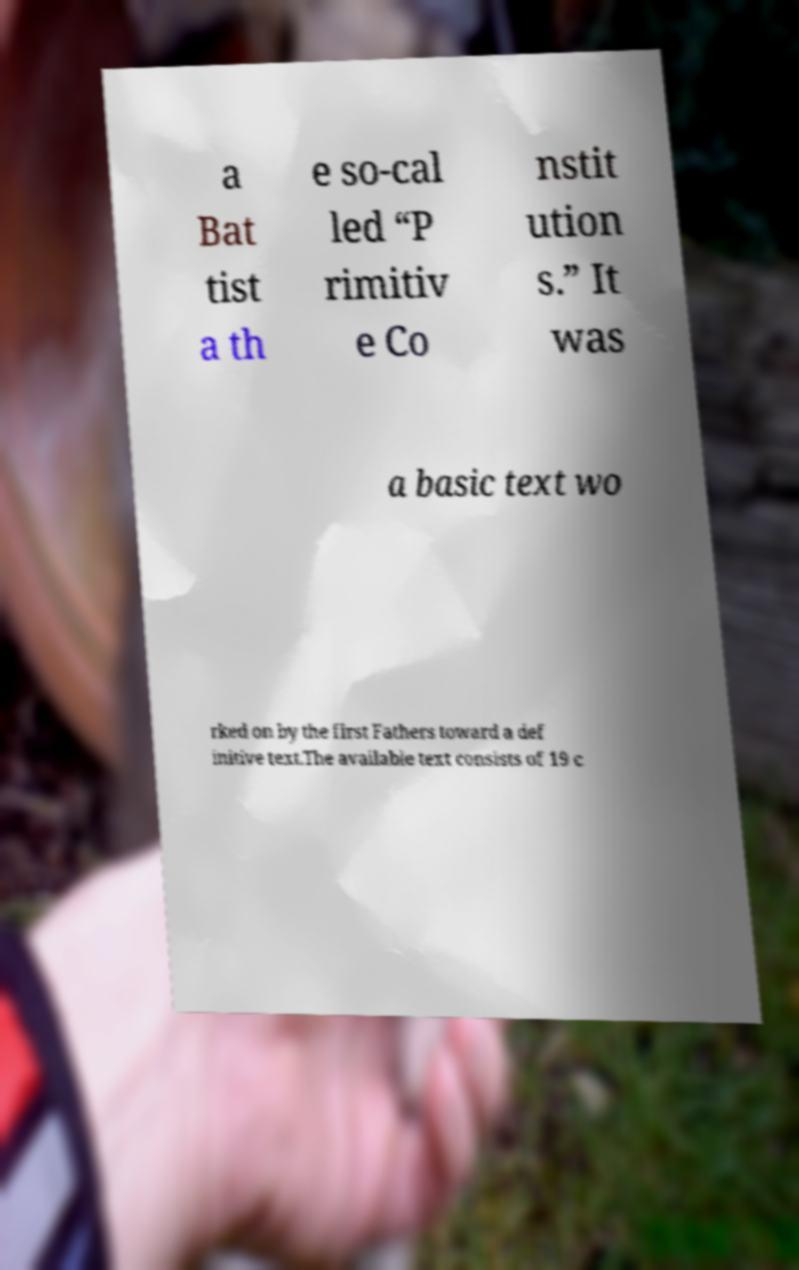For documentation purposes, I need the text within this image transcribed. Could you provide that? a Bat tist a th e so-cal led “P rimitiv e Co nstit ution s.” It was a basic text wo rked on by the first Fathers toward a def initive text.The available text consists of 19 c 